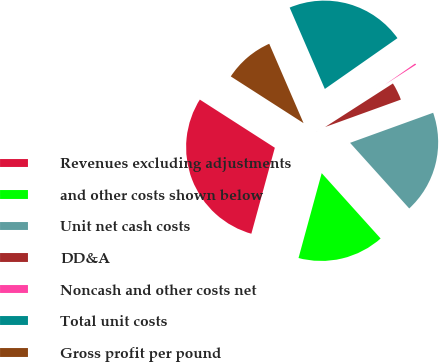Convert chart. <chart><loc_0><loc_0><loc_500><loc_500><pie_chart><fcel>Revenues excluding adjustments<fcel>and other costs shown below<fcel>Unit net cash costs<fcel>DD&A<fcel>Noncash and other costs net<fcel>Total unit costs<fcel>Gross profit per pound<nl><fcel>29.84%<fcel>15.92%<fcel>18.85%<fcel>3.56%<fcel>0.63%<fcel>21.78%<fcel>9.42%<nl></chart> 